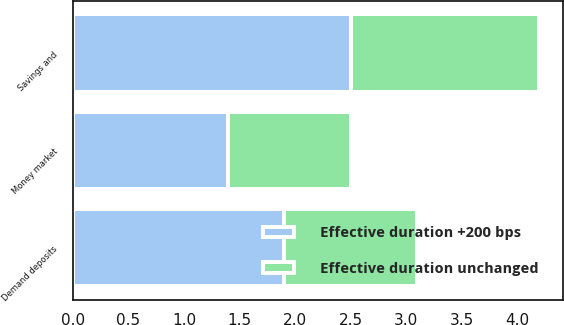<chart> <loc_0><loc_0><loc_500><loc_500><stacked_bar_chart><ecel><fcel>Demand deposits<fcel>Money market<fcel>Savings and<nl><fcel>Effective duration +200 bps<fcel>1.9<fcel>1.4<fcel>2.5<nl><fcel>Effective duration unchanged<fcel>1.2<fcel>1.1<fcel>1.7<nl></chart> 